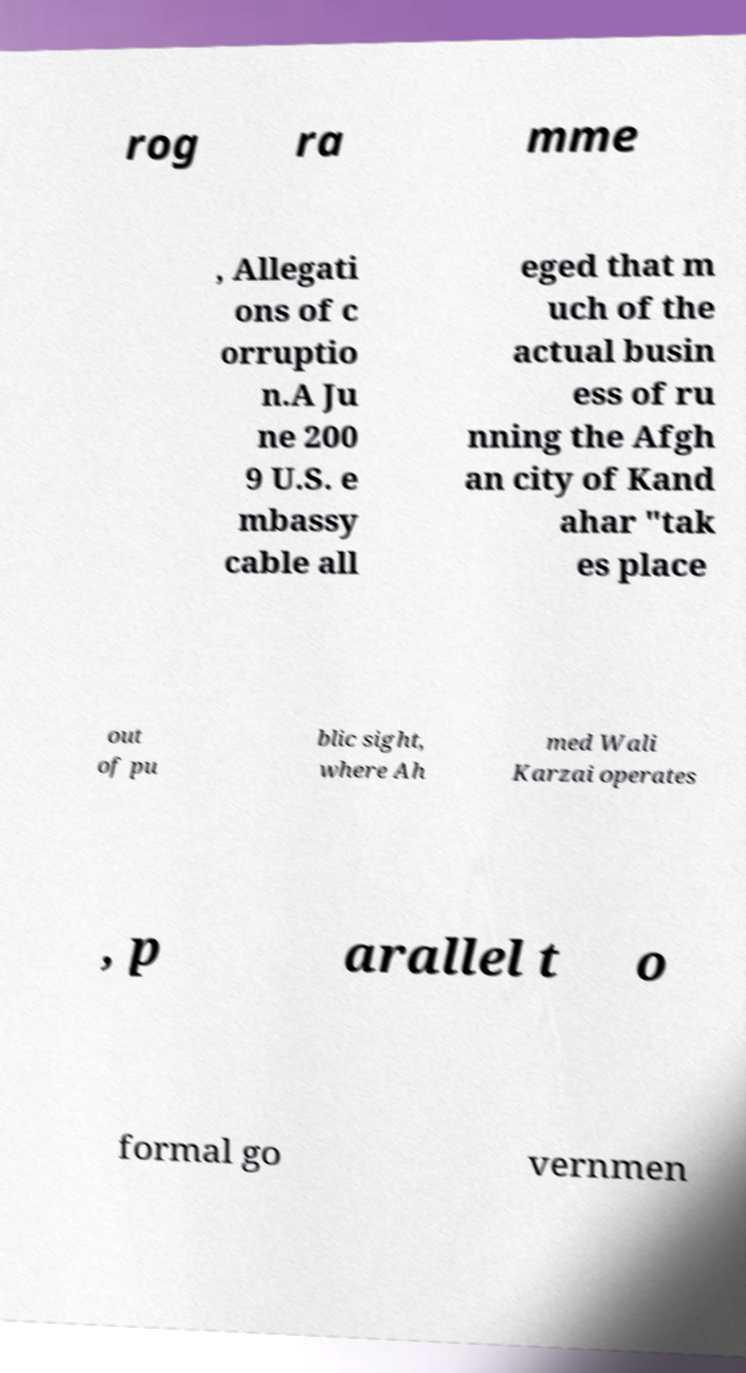Please identify and transcribe the text found in this image. rog ra mme , Allegati ons of c orruptio n.A Ju ne 200 9 U.S. e mbassy cable all eged that m uch of the actual busin ess of ru nning the Afgh an city of Kand ahar "tak es place out of pu blic sight, where Ah med Wali Karzai operates , p arallel t o formal go vernmen 